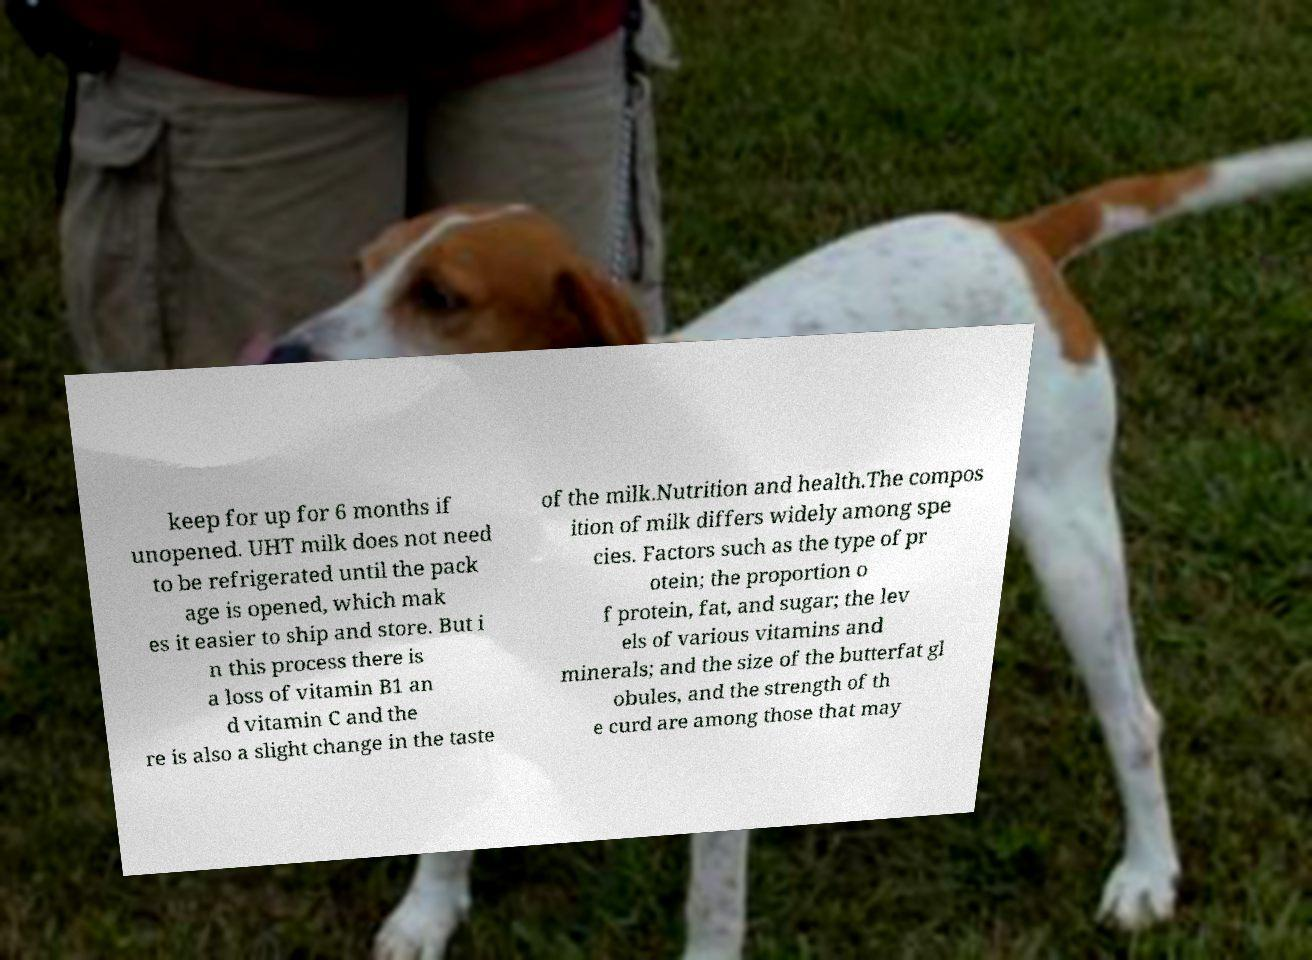Can you accurately transcribe the text from the provided image for me? keep for up for 6 months if unopened. UHT milk does not need to be refrigerated until the pack age is opened, which mak es it easier to ship and store. But i n this process there is a loss of vitamin B1 an d vitamin C and the re is also a slight change in the taste of the milk.Nutrition and health.The compos ition of milk differs widely among spe cies. Factors such as the type of pr otein; the proportion o f protein, fat, and sugar; the lev els of various vitamins and minerals; and the size of the butterfat gl obules, and the strength of th e curd are among those that may 